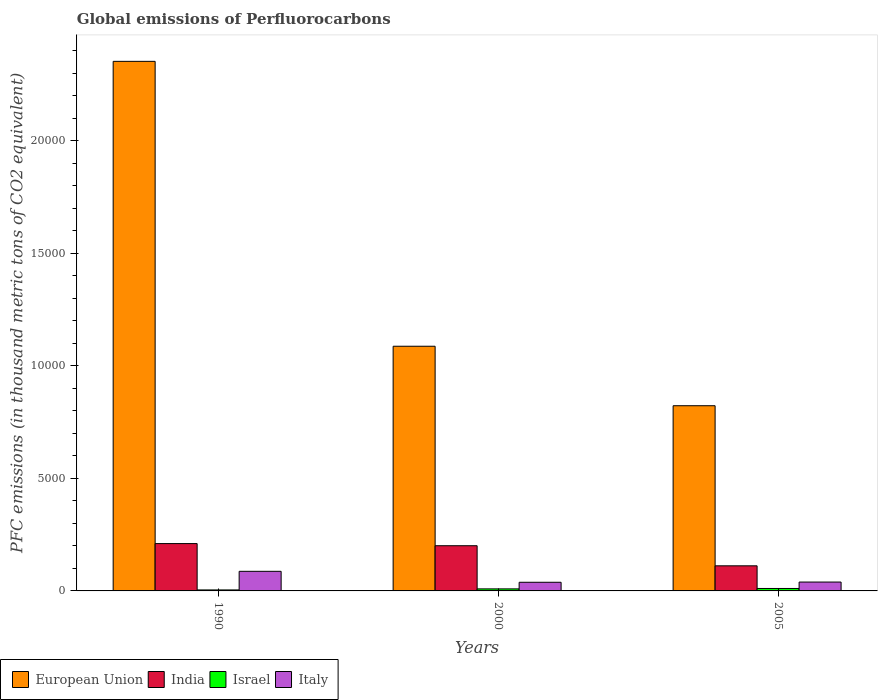Are the number of bars per tick equal to the number of legend labels?
Ensure brevity in your answer.  Yes. How many bars are there on the 2nd tick from the left?
Your answer should be very brief. 4. What is the label of the 3rd group of bars from the left?
Keep it short and to the point. 2005. In how many cases, is the number of bars for a given year not equal to the number of legend labels?
Offer a terse response. 0. What is the global emissions of Perfluorocarbons in European Union in 1990?
Make the answer very short. 2.35e+04. Across all years, what is the maximum global emissions of Perfluorocarbons in Israel?
Ensure brevity in your answer.  108.7. Across all years, what is the minimum global emissions of Perfluorocarbons in Italy?
Your answer should be very brief. 384.3. In which year was the global emissions of Perfluorocarbons in Israel maximum?
Offer a terse response. 2005. What is the total global emissions of Perfluorocarbons in Italy in the graph?
Give a very brief answer. 1649.6. What is the difference between the global emissions of Perfluorocarbons in Israel in 2000 and that in 2005?
Your answer should be compact. -18.2. What is the difference between the global emissions of Perfluorocarbons in India in 2005 and the global emissions of Perfluorocarbons in European Union in 1990?
Your response must be concise. -2.24e+04. What is the average global emissions of Perfluorocarbons in India per year?
Offer a terse response. 1742.87. In the year 1990, what is the difference between the global emissions of Perfluorocarbons in European Union and global emissions of Perfluorocarbons in Israel?
Your answer should be very brief. 2.35e+04. In how many years, is the global emissions of Perfluorocarbons in Israel greater than 1000 thousand metric tons?
Your response must be concise. 0. What is the ratio of the global emissions of Perfluorocarbons in India in 1990 to that in 2000?
Provide a succinct answer. 1.05. What is the difference between the highest and the second highest global emissions of Perfluorocarbons in European Union?
Your answer should be very brief. 1.27e+04. What is the difference between the highest and the lowest global emissions of Perfluorocarbons in India?
Give a very brief answer. 988.2. Is it the case that in every year, the sum of the global emissions of Perfluorocarbons in Israel and global emissions of Perfluorocarbons in India is greater than the sum of global emissions of Perfluorocarbons in Italy and global emissions of Perfluorocarbons in European Union?
Make the answer very short. Yes. How many years are there in the graph?
Make the answer very short. 3. What is the difference between two consecutive major ticks on the Y-axis?
Make the answer very short. 5000. Does the graph contain any zero values?
Provide a succinct answer. No. Does the graph contain grids?
Your answer should be very brief. No. What is the title of the graph?
Provide a short and direct response. Global emissions of Perfluorocarbons. What is the label or title of the X-axis?
Make the answer very short. Years. What is the label or title of the Y-axis?
Make the answer very short. PFC emissions (in thousand metric tons of CO2 equivalent). What is the PFC emissions (in thousand metric tons of CO2 equivalent) of European Union in 1990?
Your answer should be compact. 2.35e+04. What is the PFC emissions (in thousand metric tons of CO2 equivalent) of India in 1990?
Make the answer very short. 2104. What is the PFC emissions (in thousand metric tons of CO2 equivalent) of Israel in 1990?
Your answer should be compact. 43.8. What is the PFC emissions (in thousand metric tons of CO2 equivalent) of Italy in 1990?
Offer a terse response. 871. What is the PFC emissions (in thousand metric tons of CO2 equivalent) of European Union in 2000?
Offer a very short reply. 1.09e+04. What is the PFC emissions (in thousand metric tons of CO2 equivalent) of India in 2000?
Offer a very short reply. 2008.8. What is the PFC emissions (in thousand metric tons of CO2 equivalent) in Israel in 2000?
Ensure brevity in your answer.  90.5. What is the PFC emissions (in thousand metric tons of CO2 equivalent) in Italy in 2000?
Offer a very short reply. 384.3. What is the PFC emissions (in thousand metric tons of CO2 equivalent) in European Union in 2005?
Offer a very short reply. 8230.79. What is the PFC emissions (in thousand metric tons of CO2 equivalent) of India in 2005?
Offer a terse response. 1115.8. What is the PFC emissions (in thousand metric tons of CO2 equivalent) of Israel in 2005?
Ensure brevity in your answer.  108.7. What is the PFC emissions (in thousand metric tons of CO2 equivalent) of Italy in 2005?
Make the answer very short. 394.3. Across all years, what is the maximum PFC emissions (in thousand metric tons of CO2 equivalent) in European Union?
Give a very brief answer. 2.35e+04. Across all years, what is the maximum PFC emissions (in thousand metric tons of CO2 equivalent) in India?
Offer a terse response. 2104. Across all years, what is the maximum PFC emissions (in thousand metric tons of CO2 equivalent) of Israel?
Your answer should be compact. 108.7. Across all years, what is the maximum PFC emissions (in thousand metric tons of CO2 equivalent) of Italy?
Your answer should be very brief. 871. Across all years, what is the minimum PFC emissions (in thousand metric tons of CO2 equivalent) of European Union?
Provide a short and direct response. 8230.79. Across all years, what is the minimum PFC emissions (in thousand metric tons of CO2 equivalent) in India?
Provide a short and direct response. 1115.8. Across all years, what is the minimum PFC emissions (in thousand metric tons of CO2 equivalent) of Israel?
Keep it short and to the point. 43.8. Across all years, what is the minimum PFC emissions (in thousand metric tons of CO2 equivalent) in Italy?
Offer a terse response. 384.3. What is the total PFC emissions (in thousand metric tons of CO2 equivalent) in European Union in the graph?
Offer a very short reply. 4.26e+04. What is the total PFC emissions (in thousand metric tons of CO2 equivalent) in India in the graph?
Provide a succinct answer. 5228.6. What is the total PFC emissions (in thousand metric tons of CO2 equivalent) of Israel in the graph?
Your answer should be very brief. 243. What is the total PFC emissions (in thousand metric tons of CO2 equivalent) in Italy in the graph?
Provide a succinct answer. 1649.6. What is the difference between the PFC emissions (in thousand metric tons of CO2 equivalent) in European Union in 1990 and that in 2000?
Provide a succinct answer. 1.27e+04. What is the difference between the PFC emissions (in thousand metric tons of CO2 equivalent) in India in 1990 and that in 2000?
Provide a succinct answer. 95.2. What is the difference between the PFC emissions (in thousand metric tons of CO2 equivalent) of Israel in 1990 and that in 2000?
Offer a very short reply. -46.7. What is the difference between the PFC emissions (in thousand metric tons of CO2 equivalent) in Italy in 1990 and that in 2000?
Make the answer very short. 486.7. What is the difference between the PFC emissions (in thousand metric tons of CO2 equivalent) of European Union in 1990 and that in 2005?
Provide a succinct answer. 1.53e+04. What is the difference between the PFC emissions (in thousand metric tons of CO2 equivalent) of India in 1990 and that in 2005?
Provide a succinct answer. 988.2. What is the difference between the PFC emissions (in thousand metric tons of CO2 equivalent) of Israel in 1990 and that in 2005?
Provide a short and direct response. -64.9. What is the difference between the PFC emissions (in thousand metric tons of CO2 equivalent) of Italy in 1990 and that in 2005?
Provide a succinct answer. 476.7. What is the difference between the PFC emissions (in thousand metric tons of CO2 equivalent) of European Union in 2000 and that in 2005?
Make the answer very short. 2643.81. What is the difference between the PFC emissions (in thousand metric tons of CO2 equivalent) in India in 2000 and that in 2005?
Offer a very short reply. 893. What is the difference between the PFC emissions (in thousand metric tons of CO2 equivalent) in Israel in 2000 and that in 2005?
Your response must be concise. -18.2. What is the difference between the PFC emissions (in thousand metric tons of CO2 equivalent) of Italy in 2000 and that in 2005?
Give a very brief answer. -10. What is the difference between the PFC emissions (in thousand metric tons of CO2 equivalent) of European Union in 1990 and the PFC emissions (in thousand metric tons of CO2 equivalent) of India in 2000?
Provide a succinct answer. 2.15e+04. What is the difference between the PFC emissions (in thousand metric tons of CO2 equivalent) in European Union in 1990 and the PFC emissions (in thousand metric tons of CO2 equivalent) in Israel in 2000?
Offer a terse response. 2.34e+04. What is the difference between the PFC emissions (in thousand metric tons of CO2 equivalent) in European Union in 1990 and the PFC emissions (in thousand metric tons of CO2 equivalent) in Italy in 2000?
Provide a short and direct response. 2.32e+04. What is the difference between the PFC emissions (in thousand metric tons of CO2 equivalent) of India in 1990 and the PFC emissions (in thousand metric tons of CO2 equivalent) of Israel in 2000?
Your answer should be very brief. 2013.5. What is the difference between the PFC emissions (in thousand metric tons of CO2 equivalent) of India in 1990 and the PFC emissions (in thousand metric tons of CO2 equivalent) of Italy in 2000?
Offer a terse response. 1719.7. What is the difference between the PFC emissions (in thousand metric tons of CO2 equivalent) in Israel in 1990 and the PFC emissions (in thousand metric tons of CO2 equivalent) in Italy in 2000?
Your answer should be compact. -340.5. What is the difference between the PFC emissions (in thousand metric tons of CO2 equivalent) in European Union in 1990 and the PFC emissions (in thousand metric tons of CO2 equivalent) in India in 2005?
Provide a succinct answer. 2.24e+04. What is the difference between the PFC emissions (in thousand metric tons of CO2 equivalent) of European Union in 1990 and the PFC emissions (in thousand metric tons of CO2 equivalent) of Israel in 2005?
Your response must be concise. 2.34e+04. What is the difference between the PFC emissions (in thousand metric tons of CO2 equivalent) in European Union in 1990 and the PFC emissions (in thousand metric tons of CO2 equivalent) in Italy in 2005?
Make the answer very short. 2.31e+04. What is the difference between the PFC emissions (in thousand metric tons of CO2 equivalent) in India in 1990 and the PFC emissions (in thousand metric tons of CO2 equivalent) in Israel in 2005?
Your answer should be compact. 1995.3. What is the difference between the PFC emissions (in thousand metric tons of CO2 equivalent) of India in 1990 and the PFC emissions (in thousand metric tons of CO2 equivalent) of Italy in 2005?
Your answer should be compact. 1709.7. What is the difference between the PFC emissions (in thousand metric tons of CO2 equivalent) of Israel in 1990 and the PFC emissions (in thousand metric tons of CO2 equivalent) of Italy in 2005?
Your response must be concise. -350.5. What is the difference between the PFC emissions (in thousand metric tons of CO2 equivalent) in European Union in 2000 and the PFC emissions (in thousand metric tons of CO2 equivalent) in India in 2005?
Ensure brevity in your answer.  9758.8. What is the difference between the PFC emissions (in thousand metric tons of CO2 equivalent) in European Union in 2000 and the PFC emissions (in thousand metric tons of CO2 equivalent) in Israel in 2005?
Provide a succinct answer. 1.08e+04. What is the difference between the PFC emissions (in thousand metric tons of CO2 equivalent) of European Union in 2000 and the PFC emissions (in thousand metric tons of CO2 equivalent) of Italy in 2005?
Ensure brevity in your answer.  1.05e+04. What is the difference between the PFC emissions (in thousand metric tons of CO2 equivalent) of India in 2000 and the PFC emissions (in thousand metric tons of CO2 equivalent) of Israel in 2005?
Make the answer very short. 1900.1. What is the difference between the PFC emissions (in thousand metric tons of CO2 equivalent) in India in 2000 and the PFC emissions (in thousand metric tons of CO2 equivalent) in Italy in 2005?
Your response must be concise. 1614.5. What is the difference between the PFC emissions (in thousand metric tons of CO2 equivalent) in Israel in 2000 and the PFC emissions (in thousand metric tons of CO2 equivalent) in Italy in 2005?
Your answer should be compact. -303.8. What is the average PFC emissions (in thousand metric tons of CO2 equivalent) of European Union per year?
Your response must be concise. 1.42e+04. What is the average PFC emissions (in thousand metric tons of CO2 equivalent) in India per year?
Make the answer very short. 1742.87. What is the average PFC emissions (in thousand metric tons of CO2 equivalent) of Israel per year?
Offer a very short reply. 81. What is the average PFC emissions (in thousand metric tons of CO2 equivalent) of Italy per year?
Offer a terse response. 549.87. In the year 1990, what is the difference between the PFC emissions (in thousand metric tons of CO2 equivalent) in European Union and PFC emissions (in thousand metric tons of CO2 equivalent) in India?
Keep it short and to the point. 2.14e+04. In the year 1990, what is the difference between the PFC emissions (in thousand metric tons of CO2 equivalent) in European Union and PFC emissions (in thousand metric tons of CO2 equivalent) in Israel?
Provide a succinct answer. 2.35e+04. In the year 1990, what is the difference between the PFC emissions (in thousand metric tons of CO2 equivalent) in European Union and PFC emissions (in thousand metric tons of CO2 equivalent) in Italy?
Your answer should be very brief. 2.27e+04. In the year 1990, what is the difference between the PFC emissions (in thousand metric tons of CO2 equivalent) of India and PFC emissions (in thousand metric tons of CO2 equivalent) of Israel?
Make the answer very short. 2060.2. In the year 1990, what is the difference between the PFC emissions (in thousand metric tons of CO2 equivalent) of India and PFC emissions (in thousand metric tons of CO2 equivalent) of Italy?
Your answer should be compact. 1233. In the year 1990, what is the difference between the PFC emissions (in thousand metric tons of CO2 equivalent) in Israel and PFC emissions (in thousand metric tons of CO2 equivalent) in Italy?
Ensure brevity in your answer.  -827.2. In the year 2000, what is the difference between the PFC emissions (in thousand metric tons of CO2 equivalent) in European Union and PFC emissions (in thousand metric tons of CO2 equivalent) in India?
Your answer should be very brief. 8865.8. In the year 2000, what is the difference between the PFC emissions (in thousand metric tons of CO2 equivalent) in European Union and PFC emissions (in thousand metric tons of CO2 equivalent) in Israel?
Provide a succinct answer. 1.08e+04. In the year 2000, what is the difference between the PFC emissions (in thousand metric tons of CO2 equivalent) of European Union and PFC emissions (in thousand metric tons of CO2 equivalent) of Italy?
Ensure brevity in your answer.  1.05e+04. In the year 2000, what is the difference between the PFC emissions (in thousand metric tons of CO2 equivalent) in India and PFC emissions (in thousand metric tons of CO2 equivalent) in Israel?
Provide a succinct answer. 1918.3. In the year 2000, what is the difference between the PFC emissions (in thousand metric tons of CO2 equivalent) of India and PFC emissions (in thousand metric tons of CO2 equivalent) of Italy?
Offer a terse response. 1624.5. In the year 2000, what is the difference between the PFC emissions (in thousand metric tons of CO2 equivalent) in Israel and PFC emissions (in thousand metric tons of CO2 equivalent) in Italy?
Make the answer very short. -293.8. In the year 2005, what is the difference between the PFC emissions (in thousand metric tons of CO2 equivalent) in European Union and PFC emissions (in thousand metric tons of CO2 equivalent) in India?
Provide a short and direct response. 7114.99. In the year 2005, what is the difference between the PFC emissions (in thousand metric tons of CO2 equivalent) of European Union and PFC emissions (in thousand metric tons of CO2 equivalent) of Israel?
Provide a short and direct response. 8122.09. In the year 2005, what is the difference between the PFC emissions (in thousand metric tons of CO2 equivalent) in European Union and PFC emissions (in thousand metric tons of CO2 equivalent) in Italy?
Your answer should be very brief. 7836.49. In the year 2005, what is the difference between the PFC emissions (in thousand metric tons of CO2 equivalent) of India and PFC emissions (in thousand metric tons of CO2 equivalent) of Israel?
Ensure brevity in your answer.  1007.1. In the year 2005, what is the difference between the PFC emissions (in thousand metric tons of CO2 equivalent) of India and PFC emissions (in thousand metric tons of CO2 equivalent) of Italy?
Provide a short and direct response. 721.5. In the year 2005, what is the difference between the PFC emissions (in thousand metric tons of CO2 equivalent) in Israel and PFC emissions (in thousand metric tons of CO2 equivalent) in Italy?
Provide a short and direct response. -285.6. What is the ratio of the PFC emissions (in thousand metric tons of CO2 equivalent) of European Union in 1990 to that in 2000?
Ensure brevity in your answer.  2.16. What is the ratio of the PFC emissions (in thousand metric tons of CO2 equivalent) in India in 1990 to that in 2000?
Your response must be concise. 1.05. What is the ratio of the PFC emissions (in thousand metric tons of CO2 equivalent) of Israel in 1990 to that in 2000?
Offer a terse response. 0.48. What is the ratio of the PFC emissions (in thousand metric tons of CO2 equivalent) of Italy in 1990 to that in 2000?
Provide a short and direct response. 2.27. What is the ratio of the PFC emissions (in thousand metric tons of CO2 equivalent) of European Union in 1990 to that in 2005?
Offer a terse response. 2.86. What is the ratio of the PFC emissions (in thousand metric tons of CO2 equivalent) of India in 1990 to that in 2005?
Keep it short and to the point. 1.89. What is the ratio of the PFC emissions (in thousand metric tons of CO2 equivalent) of Israel in 1990 to that in 2005?
Keep it short and to the point. 0.4. What is the ratio of the PFC emissions (in thousand metric tons of CO2 equivalent) of Italy in 1990 to that in 2005?
Make the answer very short. 2.21. What is the ratio of the PFC emissions (in thousand metric tons of CO2 equivalent) in European Union in 2000 to that in 2005?
Offer a very short reply. 1.32. What is the ratio of the PFC emissions (in thousand metric tons of CO2 equivalent) of India in 2000 to that in 2005?
Make the answer very short. 1.8. What is the ratio of the PFC emissions (in thousand metric tons of CO2 equivalent) in Israel in 2000 to that in 2005?
Your answer should be very brief. 0.83. What is the ratio of the PFC emissions (in thousand metric tons of CO2 equivalent) in Italy in 2000 to that in 2005?
Ensure brevity in your answer.  0.97. What is the difference between the highest and the second highest PFC emissions (in thousand metric tons of CO2 equivalent) of European Union?
Your response must be concise. 1.27e+04. What is the difference between the highest and the second highest PFC emissions (in thousand metric tons of CO2 equivalent) of India?
Keep it short and to the point. 95.2. What is the difference between the highest and the second highest PFC emissions (in thousand metric tons of CO2 equivalent) of Israel?
Offer a terse response. 18.2. What is the difference between the highest and the second highest PFC emissions (in thousand metric tons of CO2 equivalent) in Italy?
Your answer should be compact. 476.7. What is the difference between the highest and the lowest PFC emissions (in thousand metric tons of CO2 equivalent) of European Union?
Provide a short and direct response. 1.53e+04. What is the difference between the highest and the lowest PFC emissions (in thousand metric tons of CO2 equivalent) in India?
Provide a short and direct response. 988.2. What is the difference between the highest and the lowest PFC emissions (in thousand metric tons of CO2 equivalent) of Israel?
Your answer should be very brief. 64.9. What is the difference between the highest and the lowest PFC emissions (in thousand metric tons of CO2 equivalent) of Italy?
Provide a succinct answer. 486.7. 